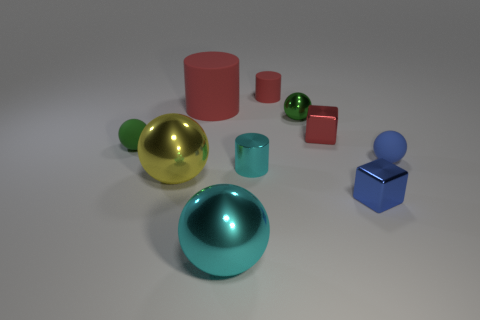Subtract all tiny blue matte spheres. How many spheres are left? 4 Subtract all yellow spheres. How many spheres are left? 4 Subtract all cubes. How many objects are left? 8 Subtract 3 spheres. How many spheres are left? 2 Subtract 0 yellow cylinders. How many objects are left? 10 Subtract all blue balls. Subtract all green cylinders. How many balls are left? 4 Subtract all red cylinders. How many yellow spheres are left? 1 Subtract all big cyan metallic spheres. Subtract all tiny blue rubber things. How many objects are left? 8 Add 6 small shiny blocks. How many small shiny blocks are left? 8 Add 1 yellow objects. How many yellow objects exist? 2 